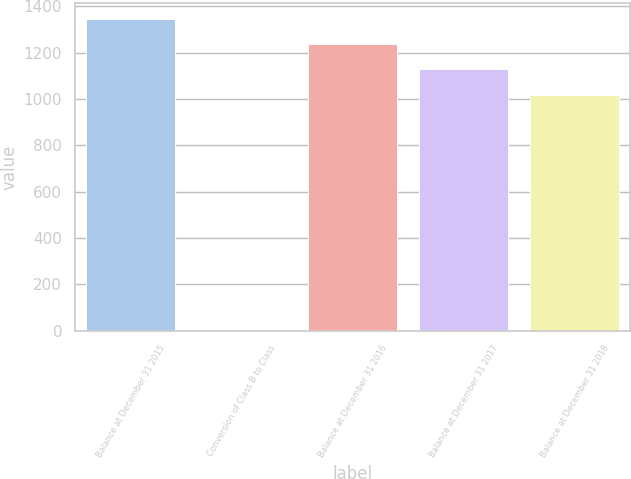<chart> <loc_0><loc_0><loc_500><loc_500><bar_chart><fcel>Balance at December 31 2015<fcel>Conversion of Class B to Class<fcel>Balance at December 31 2016<fcel>Balance at December 31 2017<fcel>Balance at December 31 2018<nl><fcel>1346.5<fcel>2<fcel>1237.2<fcel>1127.9<fcel>1018.6<nl></chart> 